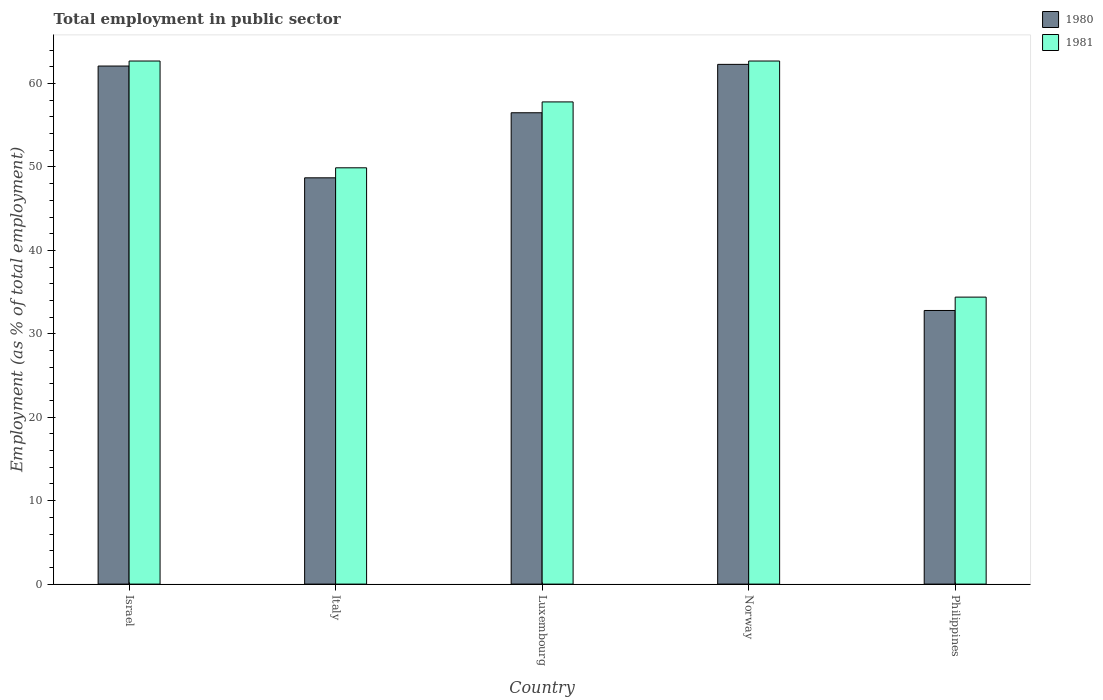How many groups of bars are there?
Make the answer very short. 5. Are the number of bars per tick equal to the number of legend labels?
Make the answer very short. Yes. Are the number of bars on each tick of the X-axis equal?
Make the answer very short. Yes. How many bars are there on the 2nd tick from the right?
Provide a succinct answer. 2. What is the label of the 4th group of bars from the left?
Provide a short and direct response. Norway. What is the employment in public sector in 1980 in Norway?
Provide a succinct answer. 62.3. Across all countries, what is the maximum employment in public sector in 1980?
Give a very brief answer. 62.3. Across all countries, what is the minimum employment in public sector in 1980?
Offer a very short reply. 32.8. What is the total employment in public sector in 1981 in the graph?
Ensure brevity in your answer.  267.5. What is the difference between the employment in public sector in 1980 in Israel and that in Luxembourg?
Offer a very short reply. 5.6. What is the difference between the employment in public sector in 1981 in Philippines and the employment in public sector in 1980 in Italy?
Make the answer very short. -14.3. What is the average employment in public sector in 1981 per country?
Offer a very short reply. 53.5. What is the difference between the employment in public sector of/in 1981 and employment in public sector of/in 1980 in Luxembourg?
Provide a succinct answer. 1.3. In how many countries, is the employment in public sector in 1980 greater than 16 %?
Make the answer very short. 5. What is the ratio of the employment in public sector in 1981 in Israel to that in Luxembourg?
Your answer should be very brief. 1.08. What is the difference between the highest and the second highest employment in public sector in 1980?
Offer a very short reply. 5.6. What is the difference between the highest and the lowest employment in public sector in 1981?
Your response must be concise. 28.3. In how many countries, is the employment in public sector in 1980 greater than the average employment in public sector in 1980 taken over all countries?
Your response must be concise. 3. Is the sum of the employment in public sector in 1981 in Israel and Italy greater than the maximum employment in public sector in 1980 across all countries?
Offer a very short reply. Yes. What does the 2nd bar from the left in Philippines represents?
Your answer should be compact. 1981. How many bars are there?
Provide a short and direct response. 10. Are all the bars in the graph horizontal?
Give a very brief answer. No. What is the difference between two consecutive major ticks on the Y-axis?
Your response must be concise. 10. Are the values on the major ticks of Y-axis written in scientific E-notation?
Ensure brevity in your answer.  No. Does the graph contain any zero values?
Give a very brief answer. No. How many legend labels are there?
Keep it short and to the point. 2. How are the legend labels stacked?
Ensure brevity in your answer.  Vertical. What is the title of the graph?
Offer a very short reply. Total employment in public sector. What is the label or title of the Y-axis?
Your answer should be compact. Employment (as % of total employment). What is the Employment (as % of total employment) in 1980 in Israel?
Provide a short and direct response. 62.1. What is the Employment (as % of total employment) in 1981 in Israel?
Make the answer very short. 62.7. What is the Employment (as % of total employment) of 1980 in Italy?
Provide a short and direct response. 48.7. What is the Employment (as % of total employment) of 1981 in Italy?
Keep it short and to the point. 49.9. What is the Employment (as % of total employment) in 1980 in Luxembourg?
Make the answer very short. 56.5. What is the Employment (as % of total employment) of 1981 in Luxembourg?
Keep it short and to the point. 57.8. What is the Employment (as % of total employment) in 1980 in Norway?
Provide a short and direct response. 62.3. What is the Employment (as % of total employment) in 1981 in Norway?
Make the answer very short. 62.7. What is the Employment (as % of total employment) in 1980 in Philippines?
Make the answer very short. 32.8. What is the Employment (as % of total employment) in 1981 in Philippines?
Make the answer very short. 34.4. Across all countries, what is the maximum Employment (as % of total employment) of 1980?
Ensure brevity in your answer.  62.3. Across all countries, what is the maximum Employment (as % of total employment) of 1981?
Ensure brevity in your answer.  62.7. Across all countries, what is the minimum Employment (as % of total employment) of 1980?
Ensure brevity in your answer.  32.8. Across all countries, what is the minimum Employment (as % of total employment) in 1981?
Ensure brevity in your answer.  34.4. What is the total Employment (as % of total employment) in 1980 in the graph?
Make the answer very short. 262.4. What is the total Employment (as % of total employment) of 1981 in the graph?
Your response must be concise. 267.5. What is the difference between the Employment (as % of total employment) in 1981 in Israel and that in Italy?
Make the answer very short. 12.8. What is the difference between the Employment (as % of total employment) of 1980 in Israel and that in Luxembourg?
Ensure brevity in your answer.  5.6. What is the difference between the Employment (as % of total employment) in 1980 in Israel and that in Philippines?
Provide a short and direct response. 29.3. What is the difference between the Employment (as % of total employment) in 1981 in Israel and that in Philippines?
Your response must be concise. 28.3. What is the difference between the Employment (as % of total employment) in 1980 in Italy and that in Luxembourg?
Your answer should be compact. -7.8. What is the difference between the Employment (as % of total employment) in 1981 in Italy and that in Luxembourg?
Provide a succinct answer. -7.9. What is the difference between the Employment (as % of total employment) of 1981 in Italy and that in Philippines?
Your response must be concise. 15.5. What is the difference between the Employment (as % of total employment) of 1980 in Luxembourg and that in Norway?
Offer a terse response. -5.8. What is the difference between the Employment (as % of total employment) in 1981 in Luxembourg and that in Norway?
Make the answer very short. -4.9. What is the difference between the Employment (as % of total employment) of 1980 in Luxembourg and that in Philippines?
Keep it short and to the point. 23.7. What is the difference between the Employment (as % of total employment) of 1981 in Luxembourg and that in Philippines?
Ensure brevity in your answer.  23.4. What is the difference between the Employment (as % of total employment) of 1980 in Norway and that in Philippines?
Your answer should be very brief. 29.5. What is the difference between the Employment (as % of total employment) of 1981 in Norway and that in Philippines?
Keep it short and to the point. 28.3. What is the difference between the Employment (as % of total employment) in 1980 in Israel and the Employment (as % of total employment) in 1981 in Italy?
Provide a short and direct response. 12.2. What is the difference between the Employment (as % of total employment) in 1980 in Israel and the Employment (as % of total employment) in 1981 in Luxembourg?
Your response must be concise. 4.3. What is the difference between the Employment (as % of total employment) of 1980 in Israel and the Employment (as % of total employment) of 1981 in Philippines?
Offer a very short reply. 27.7. What is the difference between the Employment (as % of total employment) of 1980 in Luxembourg and the Employment (as % of total employment) of 1981 in Norway?
Your response must be concise. -6.2. What is the difference between the Employment (as % of total employment) in 1980 in Luxembourg and the Employment (as % of total employment) in 1981 in Philippines?
Offer a very short reply. 22.1. What is the difference between the Employment (as % of total employment) in 1980 in Norway and the Employment (as % of total employment) in 1981 in Philippines?
Offer a very short reply. 27.9. What is the average Employment (as % of total employment) in 1980 per country?
Provide a short and direct response. 52.48. What is the average Employment (as % of total employment) of 1981 per country?
Offer a terse response. 53.5. What is the difference between the Employment (as % of total employment) of 1980 and Employment (as % of total employment) of 1981 in Israel?
Provide a short and direct response. -0.6. What is the difference between the Employment (as % of total employment) of 1980 and Employment (as % of total employment) of 1981 in Philippines?
Provide a succinct answer. -1.6. What is the ratio of the Employment (as % of total employment) in 1980 in Israel to that in Italy?
Give a very brief answer. 1.28. What is the ratio of the Employment (as % of total employment) of 1981 in Israel to that in Italy?
Make the answer very short. 1.26. What is the ratio of the Employment (as % of total employment) of 1980 in Israel to that in Luxembourg?
Your answer should be compact. 1.1. What is the ratio of the Employment (as % of total employment) of 1981 in Israel to that in Luxembourg?
Give a very brief answer. 1.08. What is the ratio of the Employment (as % of total employment) in 1980 in Israel to that in Norway?
Offer a very short reply. 1. What is the ratio of the Employment (as % of total employment) of 1981 in Israel to that in Norway?
Keep it short and to the point. 1. What is the ratio of the Employment (as % of total employment) in 1980 in Israel to that in Philippines?
Offer a very short reply. 1.89. What is the ratio of the Employment (as % of total employment) of 1981 in Israel to that in Philippines?
Keep it short and to the point. 1.82. What is the ratio of the Employment (as % of total employment) in 1980 in Italy to that in Luxembourg?
Give a very brief answer. 0.86. What is the ratio of the Employment (as % of total employment) of 1981 in Italy to that in Luxembourg?
Your response must be concise. 0.86. What is the ratio of the Employment (as % of total employment) in 1980 in Italy to that in Norway?
Offer a very short reply. 0.78. What is the ratio of the Employment (as % of total employment) in 1981 in Italy to that in Norway?
Make the answer very short. 0.8. What is the ratio of the Employment (as % of total employment) in 1980 in Italy to that in Philippines?
Give a very brief answer. 1.48. What is the ratio of the Employment (as % of total employment) of 1981 in Italy to that in Philippines?
Provide a succinct answer. 1.45. What is the ratio of the Employment (as % of total employment) of 1980 in Luxembourg to that in Norway?
Give a very brief answer. 0.91. What is the ratio of the Employment (as % of total employment) in 1981 in Luxembourg to that in Norway?
Provide a succinct answer. 0.92. What is the ratio of the Employment (as % of total employment) of 1980 in Luxembourg to that in Philippines?
Your answer should be very brief. 1.72. What is the ratio of the Employment (as % of total employment) of 1981 in Luxembourg to that in Philippines?
Make the answer very short. 1.68. What is the ratio of the Employment (as % of total employment) of 1980 in Norway to that in Philippines?
Offer a terse response. 1.9. What is the ratio of the Employment (as % of total employment) in 1981 in Norway to that in Philippines?
Make the answer very short. 1.82. What is the difference between the highest and the second highest Employment (as % of total employment) in 1981?
Offer a very short reply. 0. What is the difference between the highest and the lowest Employment (as % of total employment) in 1980?
Offer a very short reply. 29.5. What is the difference between the highest and the lowest Employment (as % of total employment) in 1981?
Offer a very short reply. 28.3. 